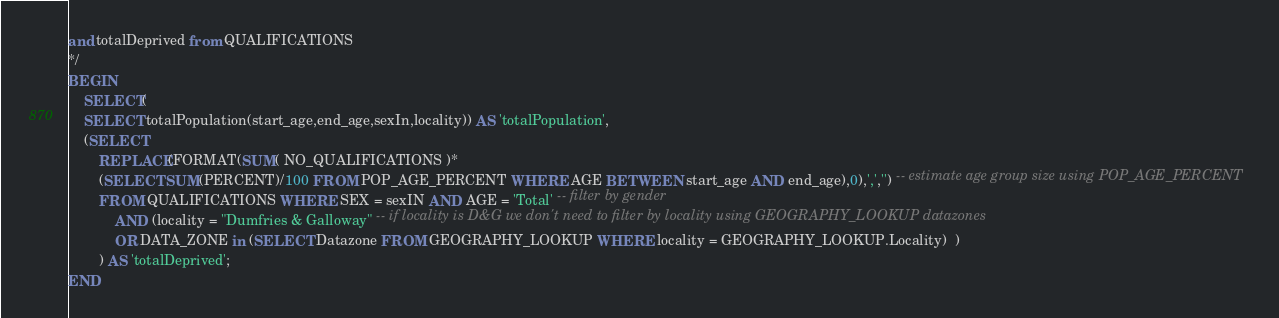Convert code to text. <code><loc_0><loc_0><loc_500><loc_500><_SQL_>and totalDeprived from QUALIFICATIONS
*/
BEGIN
	SELECT(
	SELECT totalPopulation(start_age,end_age,sexIn,locality)) AS 'totalPopulation',
    (SELECT
		REPLACE(FORMAT(SUM( NO_QUALIFICATIONS )*
        (SELECT SUM(PERCENT)/100 FROM POP_AGE_PERCENT WHERE AGE BETWEEN start_age AND end_age),0),',','') -- estimate age group size using POP_AGE_PERCENT
		FROM QUALIFICATIONS WHERE SEX = sexIN AND AGE = 'Total' -- filter by gender
			AND (locality = "Dumfries & Galloway" -- if locality is D&G we don't need to filter by locality using GEOGRAPHY_LOOKUP datazones
			OR DATA_ZONE in (SELECT Datazone FROM GEOGRAPHY_LOOKUP WHERE locality = GEOGRAPHY_LOOKUP.Locality)  )
        ) AS 'totalDeprived';
END
</code> 